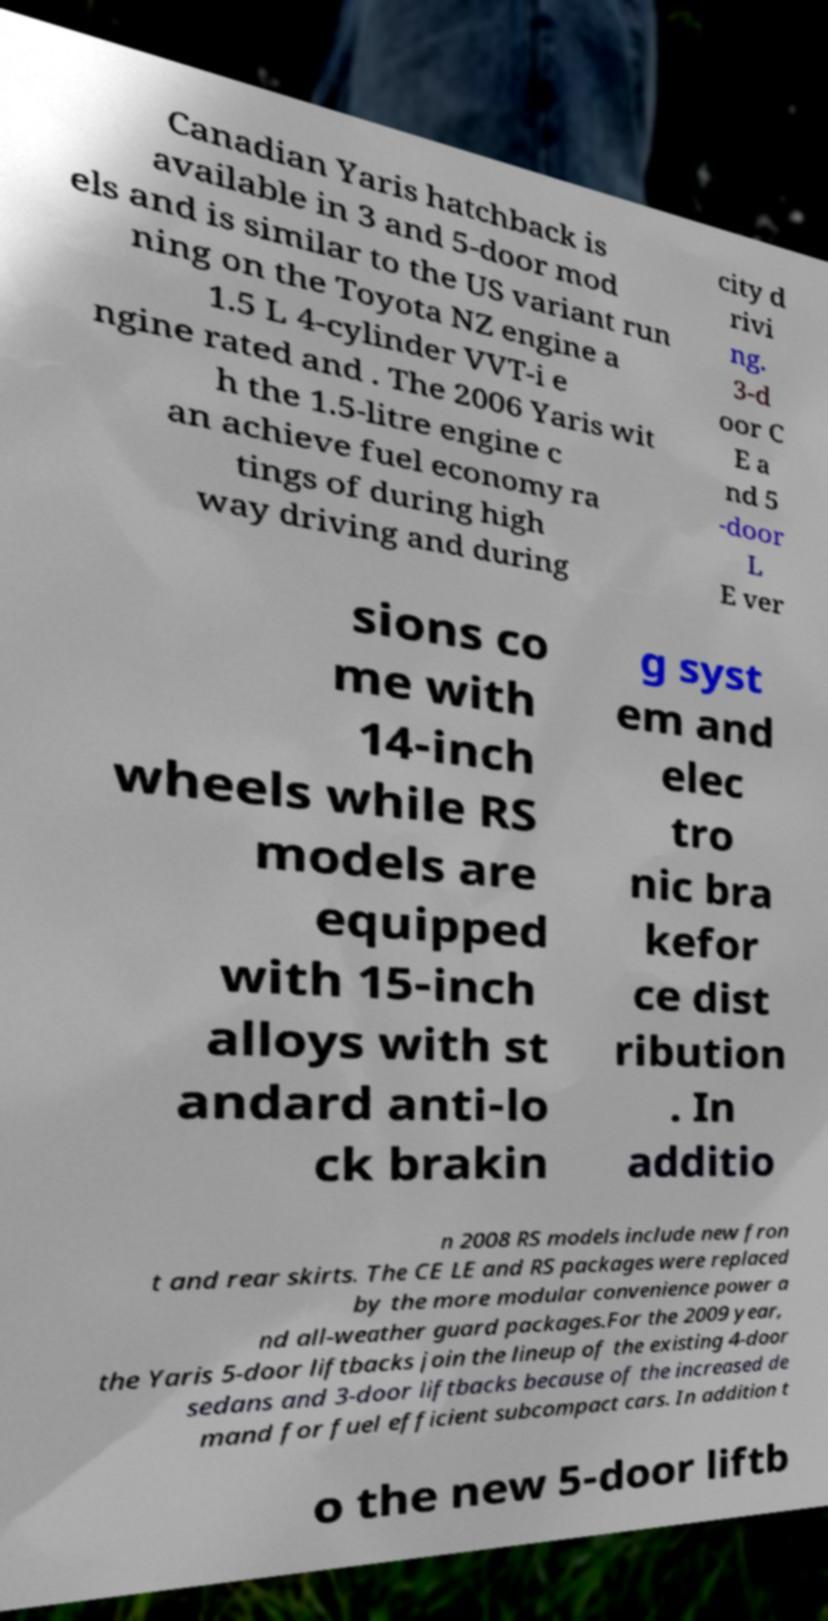For documentation purposes, I need the text within this image transcribed. Could you provide that? Canadian Yaris hatchback is available in 3 and 5-door mod els and is similar to the US variant run ning on the Toyota NZ engine a 1.5 L 4-cylinder VVT-i e ngine rated and . The 2006 Yaris wit h the 1.5-litre engine c an achieve fuel economy ra tings of during high way driving and during city d rivi ng. 3-d oor C E a nd 5 -door L E ver sions co me with 14-inch wheels while RS models are equipped with 15-inch alloys with st andard anti-lo ck brakin g syst em and elec tro nic bra kefor ce dist ribution . In additio n 2008 RS models include new fron t and rear skirts. The CE LE and RS packages were replaced by the more modular convenience power a nd all-weather guard packages.For the 2009 year, the Yaris 5-door liftbacks join the lineup of the existing 4-door sedans and 3-door liftbacks because of the increased de mand for fuel efficient subcompact cars. In addition t o the new 5-door liftb 